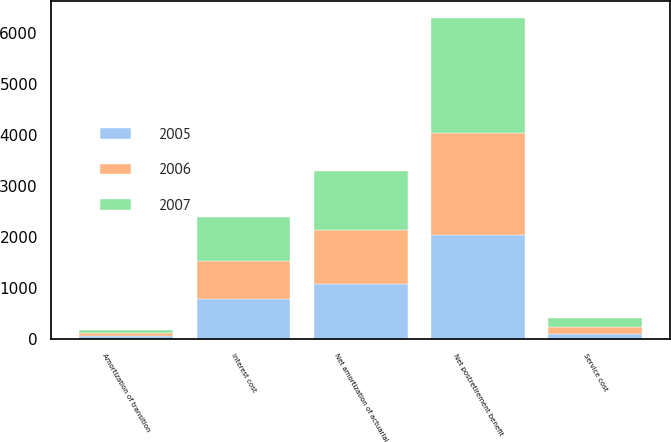Convert chart to OTSL. <chart><loc_0><loc_0><loc_500><loc_500><stacked_bar_chart><ecel><fcel>Service cost<fcel>Interest cost<fcel>Amortization of transition<fcel>Net amortization of actuarial<fcel>Net postretirement benefit<nl><fcel>2007<fcel>178<fcel>864<fcel>62<fcel>1151<fcel>2255<nl><fcel>2006<fcel>134<fcel>745<fcel>62<fcel>1069<fcel>2010<nl><fcel>2005<fcel>114<fcel>786<fcel>62<fcel>1079<fcel>2041<nl></chart> 